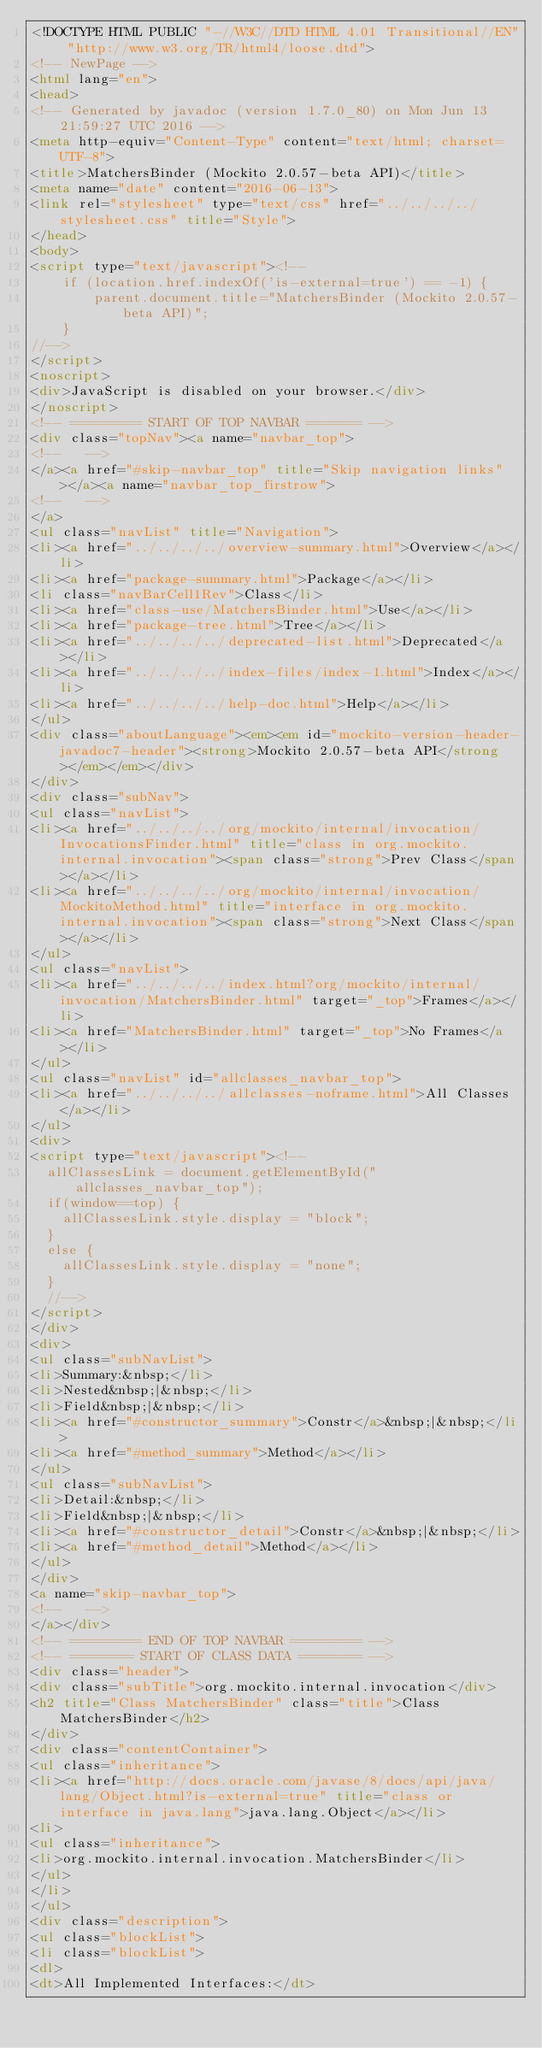Convert code to text. <code><loc_0><loc_0><loc_500><loc_500><_HTML_><!DOCTYPE HTML PUBLIC "-//W3C//DTD HTML 4.01 Transitional//EN" "http://www.w3.org/TR/html4/loose.dtd">
<!-- NewPage -->
<html lang="en">
<head>
<!-- Generated by javadoc (version 1.7.0_80) on Mon Jun 13 21:59:27 UTC 2016 -->
<meta http-equiv="Content-Type" content="text/html; charset=UTF-8">
<title>MatchersBinder (Mockito 2.0.57-beta API)</title>
<meta name="date" content="2016-06-13">
<link rel="stylesheet" type="text/css" href="../../../../stylesheet.css" title="Style">
</head>
<body>
<script type="text/javascript"><!--
    if (location.href.indexOf('is-external=true') == -1) {
        parent.document.title="MatchersBinder (Mockito 2.0.57-beta API)";
    }
//-->
</script>
<noscript>
<div>JavaScript is disabled on your browser.</div>
</noscript>
<!-- ========= START OF TOP NAVBAR ======= -->
<div class="topNav"><a name="navbar_top">
<!--   -->
</a><a href="#skip-navbar_top" title="Skip navigation links"></a><a name="navbar_top_firstrow">
<!--   -->
</a>
<ul class="navList" title="Navigation">
<li><a href="../../../../overview-summary.html">Overview</a></li>
<li><a href="package-summary.html">Package</a></li>
<li class="navBarCell1Rev">Class</li>
<li><a href="class-use/MatchersBinder.html">Use</a></li>
<li><a href="package-tree.html">Tree</a></li>
<li><a href="../../../../deprecated-list.html">Deprecated</a></li>
<li><a href="../../../../index-files/index-1.html">Index</a></li>
<li><a href="../../../../help-doc.html">Help</a></li>
</ul>
<div class="aboutLanguage"><em><em id="mockito-version-header-javadoc7-header"><strong>Mockito 2.0.57-beta API</strong></em></em></div>
</div>
<div class="subNav">
<ul class="navList">
<li><a href="../../../../org/mockito/internal/invocation/InvocationsFinder.html" title="class in org.mockito.internal.invocation"><span class="strong">Prev Class</span></a></li>
<li><a href="../../../../org/mockito/internal/invocation/MockitoMethod.html" title="interface in org.mockito.internal.invocation"><span class="strong">Next Class</span></a></li>
</ul>
<ul class="navList">
<li><a href="../../../../index.html?org/mockito/internal/invocation/MatchersBinder.html" target="_top">Frames</a></li>
<li><a href="MatchersBinder.html" target="_top">No Frames</a></li>
</ul>
<ul class="navList" id="allclasses_navbar_top">
<li><a href="../../../../allclasses-noframe.html">All Classes</a></li>
</ul>
<div>
<script type="text/javascript"><!--
  allClassesLink = document.getElementById("allclasses_navbar_top");
  if(window==top) {
    allClassesLink.style.display = "block";
  }
  else {
    allClassesLink.style.display = "none";
  }
  //-->
</script>
</div>
<div>
<ul class="subNavList">
<li>Summary:&nbsp;</li>
<li>Nested&nbsp;|&nbsp;</li>
<li>Field&nbsp;|&nbsp;</li>
<li><a href="#constructor_summary">Constr</a>&nbsp;|&nbsp;</li>
<li><a href="#method_summary">Method</a></li>
</ul>
<ul class="subNavList">
<li>Detail:&nbsp;</li>
<li>Field&nbsp;|&nbsp;</li>
<li><a href="#constructor_detail">Constr</a>&nbsp;|&nbsp;</li>
<li><a href="#method_detail">Method</a></li>
</ul>
</div>
<a name="skip-navbar_top">
<!--   -->
</a></div>
<!-- ========= END OF TOP NAVBAR ========= -->
<!-- ======== START OF CLASS DATA ======== -->
<div class="header">
<div class="subTitle">org.mockito.internal.invocation</div>
<h2 title="Class MatchersBinder" class="title">Class MatchersBinder</h2>
</div>
<div class="contentContainer">
<ul class="inheritance">
<li><a href="http://docs.oracle.com/javase/8/docs/api/java/lang/Object.html?is-external=true" title="class or interface in java.lang">java.lang.Object</a></li>
<li>
<ul class="inheritance">
<li>org.mockito.internal.invocation.MatchersBinder</li>
</ul>
</li>
</ul>
<div class="description">
<ul class="blockList">
<li class="blockList">
<dl>
<dt>All Implemented Interfaces:</dt></code> 